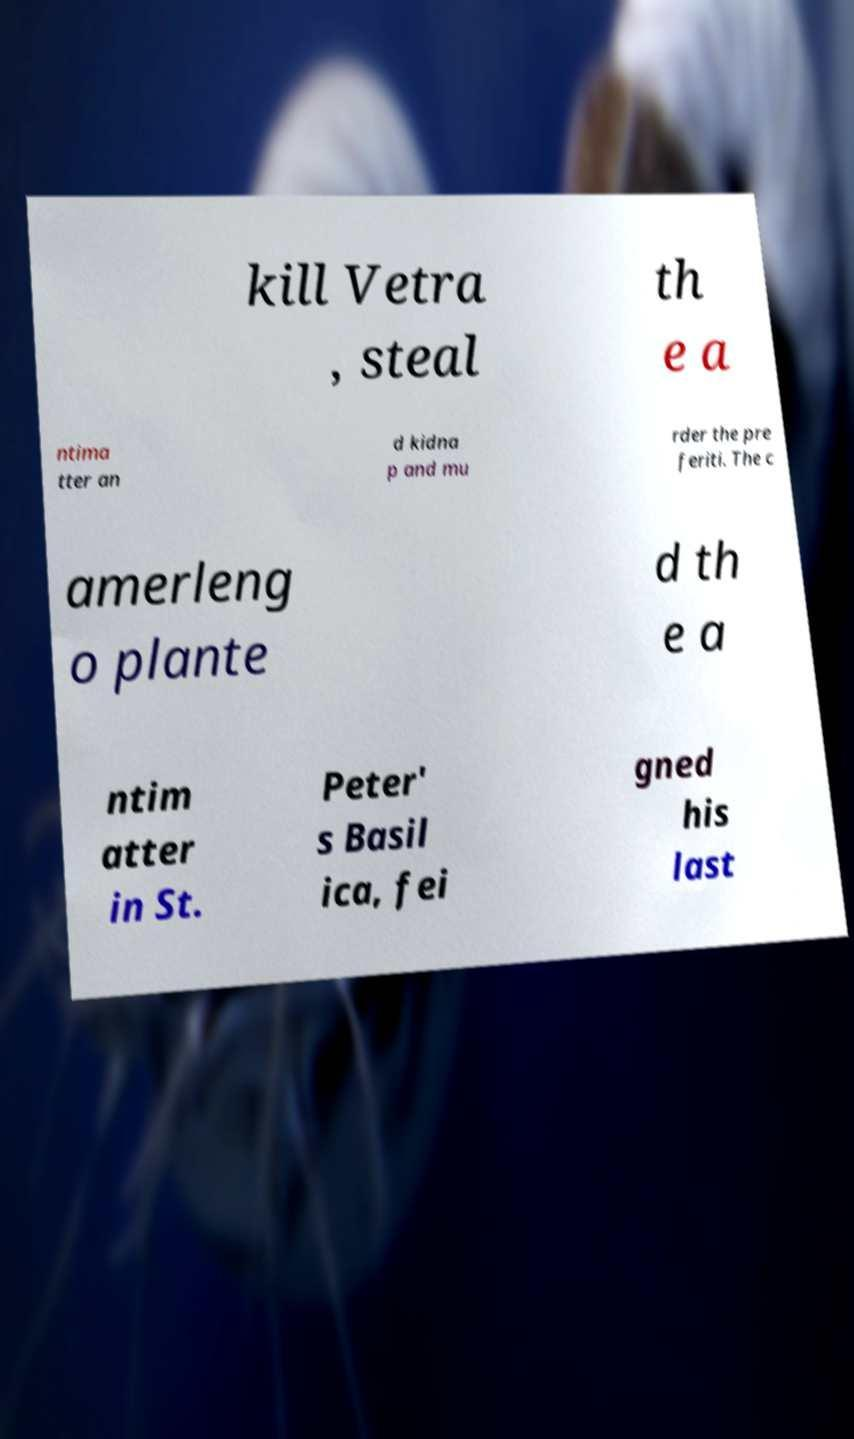Please identify and transcribe the text found in this image. kill Vetra , steal th e a ntima tter an d kidna p and mu rder the pre feriti. The c amerleng o plante d th e a ntim atter in St. Peter' s Basil ica, fei gned his last 